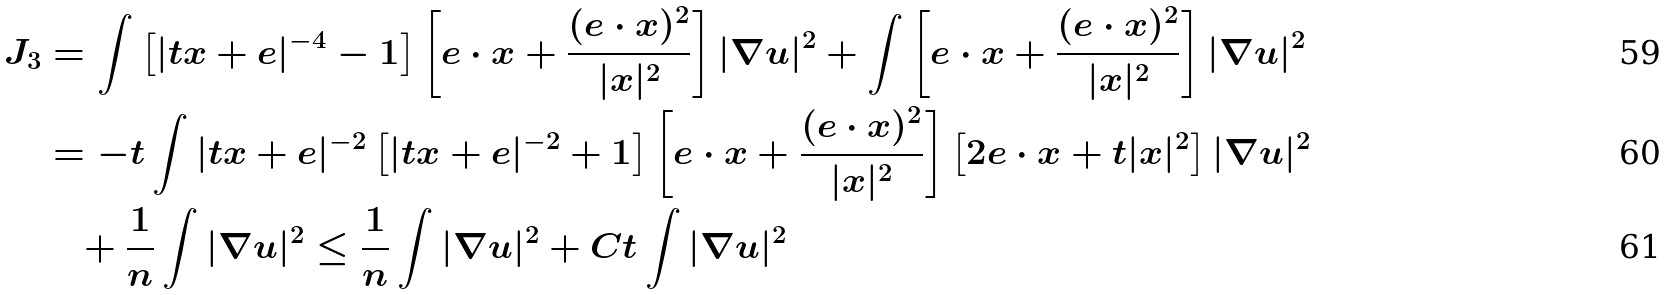Convert formula to latex. <formula><loc_0><loc_0><loc_500><loc_500>J _ { 3 } & = \int \left [ | t x + e | ^ { - 4 } - 1 \right ] \left [ e \cdot x + \frac { ( e \cdot x ) ^ { 2 } } { | x | ^ { 2 } } \right ] | \nabla u | ^ { 2 } + \int \left [ e \cdot x + \frac { ( e \cdot x ) ^ { 2 } } { | x | ^ { 2 } } \right ] | \nabla u | ^ { 2 } \\ & = - t \int | t x + e | ^ { - 2 } \left [ | t x + e | ^ { - 2 } + 1 \right ] \left [ e \cdot x + \frac { ( e \cdot x ) ^ { 2 } } { | x | ^ { 2 } } \right ] \left [ 2 e \cdot x + t | x | ^ { 2 } \right ] | \nabla u | ^ { 2 } \\ & \quad + \frac { 1 } { n } \int | \nabla u | ^ { 2 } \leq \frac { 1 } { n } \int | \nabla u | ^ { 2 } + C t \int | \nabla u | ^ { 2 }</formula> 